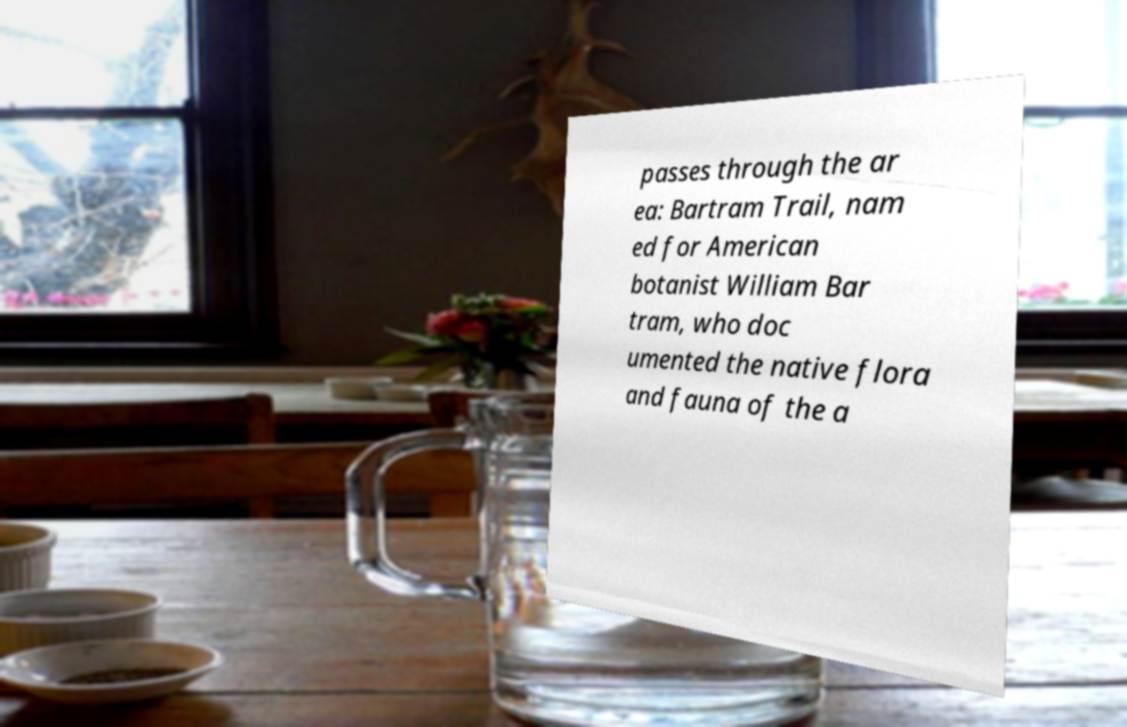Could you extract and type out the text from this image? passes through the ar ea: Bartram Trail, nam ed for American botanist William Bar tram, who doc umented the native flora and fauna of the a 